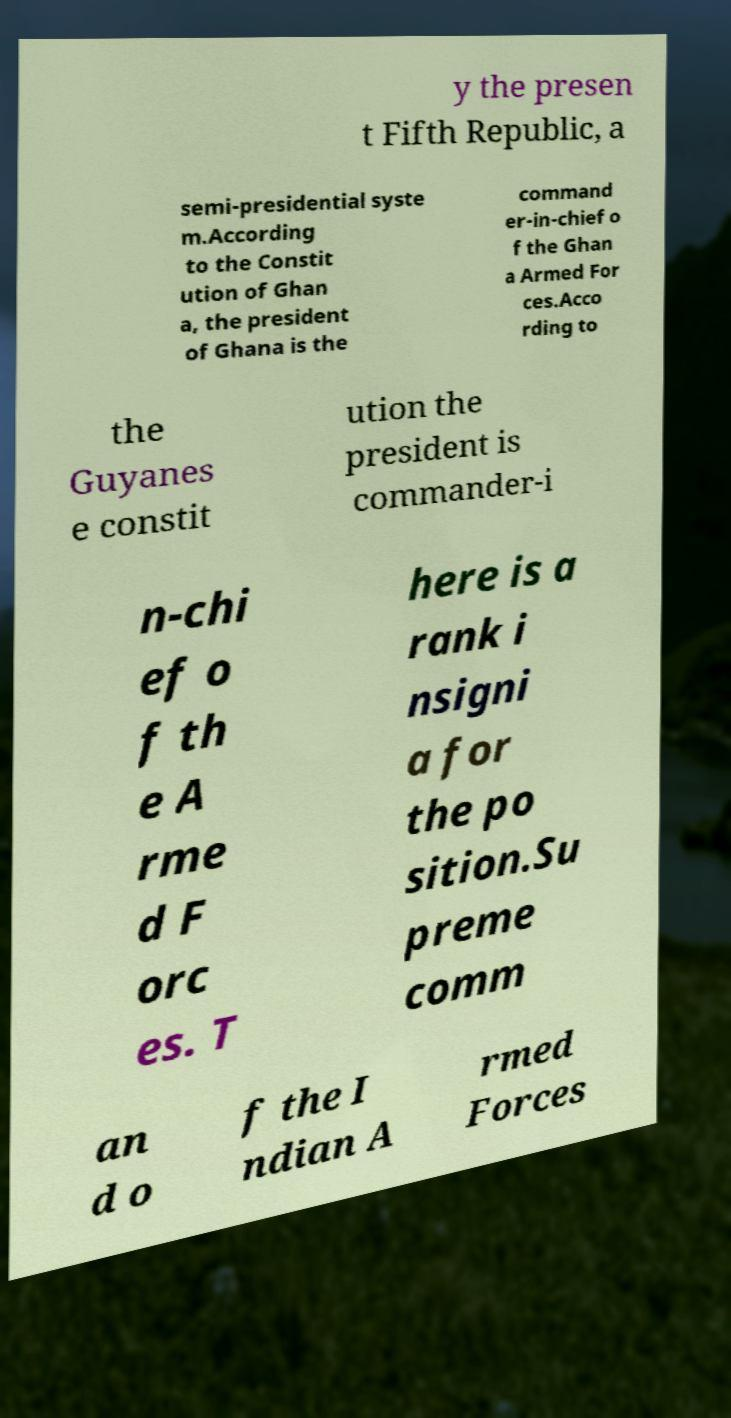I need the written content from this picture converted into text. Can you do that? y the presen t Fifth Republic, a semi-presidential syste m.According to the Constit ution of Ghan a, the president of Ghana is the command er-in-chief o f the Ghan a Armed For ces.Acco rding to the Guyanes e constit ution the president is commander-i n-chi ef o f th e A rme d F orc es. T here is a rank i nsigni a for the po sition.Su preme comm an d o f the I ndian A rmed Forces 